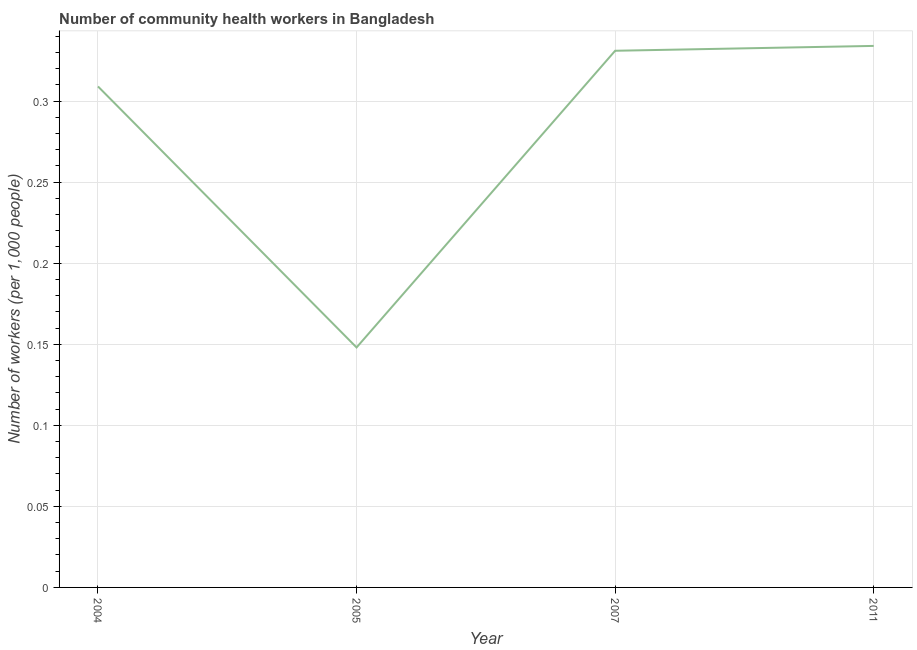What is the number of community health workers in 2011?
Your response must be concise. 0.33. Across all years, what is the maximum number of community health workers?
Offer a terse response. 0.33. Across all years, what is the minimum number of community health workers?
Offer a very short reply. 0.15. In which year was the number of community health workers minimum?
Your response must be concise. 2005. What is the sum of the number of community health workers?
Your answer should be very brief. 1.12. What is the difference between the number of community health workers in 2007 and 2011?
Provide a succinct answer. -0. What is the average number of community health workers per year?
Make the answer very short. 0.28. What is the median number of community health workers?
Offer a terse response. 0.32. Do a majority of the years between 2011 and 2005 (inclusive) have number of community health workers greater than 0.05 ?
Your answer should be very brief. No. What is the ratio of the number of community health workers in 2004 to that in 2005?
Offer a terse response. 2.09. Is the difference between the number of community health workers in 2005 and 2011 greater than the difference between any two years?
Give a very brief answer. Yes. What is the difference between the highest and the second highest number of community health workers?
Keep it short and to the point. 0. Is the sum of the number of community health workers in 2004 and 2005 greater than the maximum number of community health workers across all years?
Provide a succinct answer. Yes. What is the difference between the highest and the lowest number of community health workers?
Offer a terse response. 0.19. How many lines are there?
Make the answer very short. 1. How many years are there in the graph?
Keep it short and to the point. 4. Are the values on the major ticks of Y-axis written in scientific E-notation?
Ensure brevity in your answer.  No. Does the graph contain grids?
Provide a short and direct response. Yes. What is the title of the graph?
Ensure brevity in your answer.  Number of community health workers in Bangladesh. What is the label or title of the X-axis?
Make the answer very short. Year. What is the label or title of the Y-axis?
Your response must be concise. Number of workers (per 1,0 people). What is the Number of workers (per 1,000 people) in 2004?
Your answer should be compact. 0.31. What is the Number of workers (per 1,000 people) of 2005?
Provide a succinct answer. 0.15. What is the Number of workers (per 1,000 people) in 2007?
Provide a succinct answer. 0.33. What is the Number of workers (per 1,000 people) of 2011?
Your answer should be compact. 0.33. What is the difference between the Number of workers (per 1,000 people) in 2004 and 2005?
Keep it short and to the point. 0.16. What is the difference between the Number of workers (per 1,000 people) in 2004 and 2007?
Offer a terse response. -0.02. What is the difference between the Number of workers (per 1,000 people) in 2004 and 2011?
Keep it short and to the point. -0.03. What is the difference between the Number of workers (per 1,000 people) in 2005 and 2007?
Your answer should be compact. -0.18. What is the difference between the Number of workers (per 1,000 people) in 2005 and 2011?
Ensure brevity in your answer.  -0.19. What is the difference between the Number of workers (per 1,000 people) in 2007 and 2011?
Your response must be concise. -0. What is the ratio of the Number of workers (per 1,000 people) in 2004 to that in 2005?
Keep it short and to the point. 2.09. What is the ratio of the Number of workers (per 1,000 people) in 2004 to that in 2007?
Your response must be concise. 0.93. What is the ratio of the Number of workers (per 1,000 people) in 2004 to that in 2011?
Give a very brief answer. 0.93. What is the ratio of the Number of workers (per 1,000 people) in 2005 to that in 2007?
Your answer should be compact. 0.45. What is the ratio of the Number of workers (per 1,000 people) in 2005 to that in 2011?
Your answer should be compact. 0.44. What is the ratio of the Number of workers (per 1,000 people) in 2007 to that in 2011?
Make the answer very short. 0.99. 